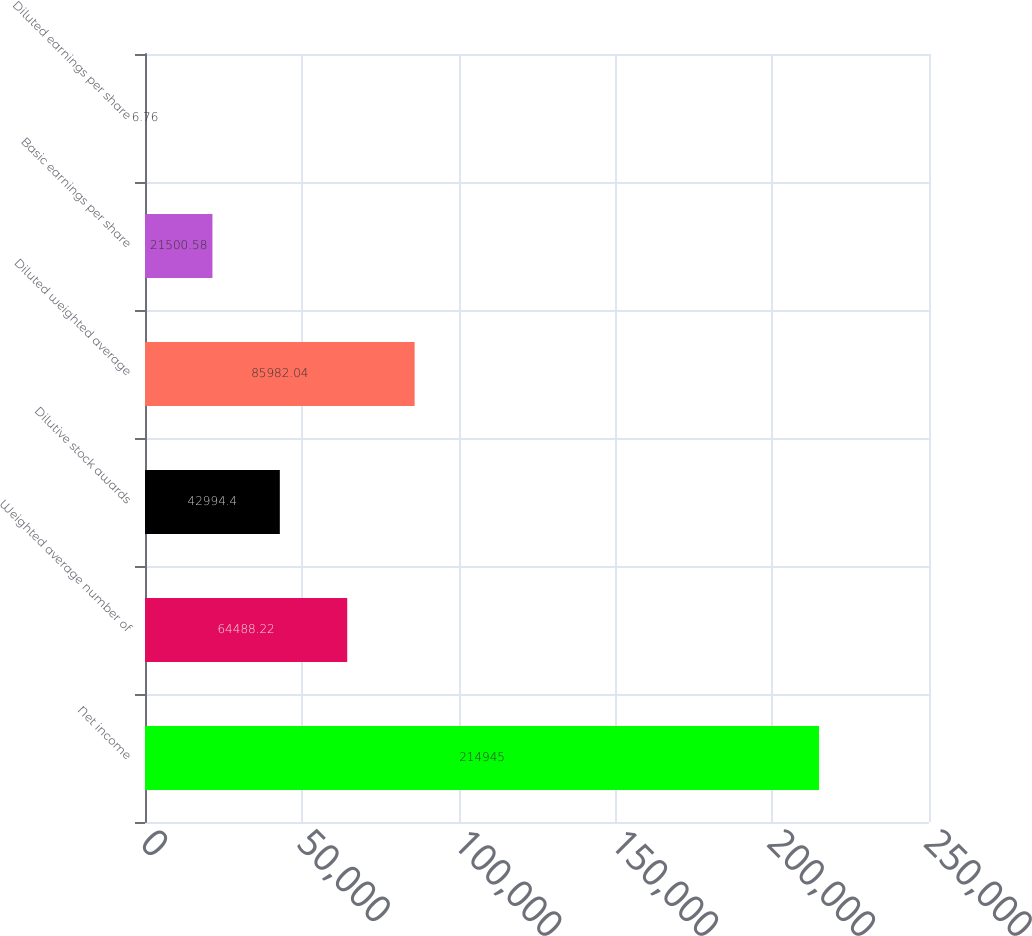Convert chart. <chart><loc_0><loc_0><loc_500><loc_500><bar_chart><fcel>Net income<fcel>Weighted average number of<fcel>Dilutive stock awards<fcel>Diluted weighted average<fcel>Basic earnings per share<fcel>Diluted earnings per share<nl><fcel>214945<fcel>64488.2<fcel>42994.4<fcel>85982<fcel>21500.6<fcel>6.76<nl></chart> 